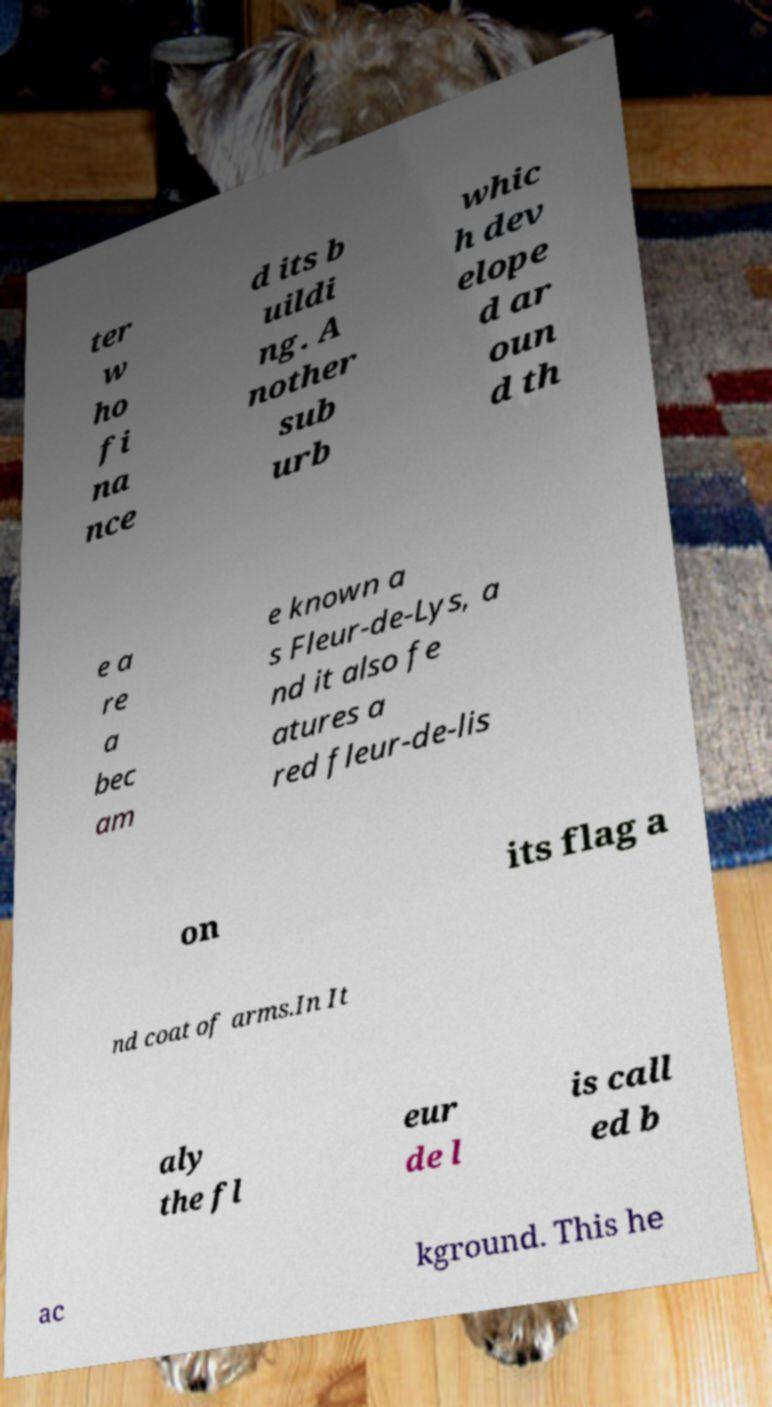Please read and relay the text visible in this image. What does it say? ter w ho fi na nce d its b uildi ng. A nother sub urb whic h dev elope d ar oun d th e a re a bec am e known a s Fleur-de-Lys, a nd it also fe atures a red fleur-de-lis on its flag a nd coat of arms.In It aly the fl eur de l is call ed b ac kground. This he 